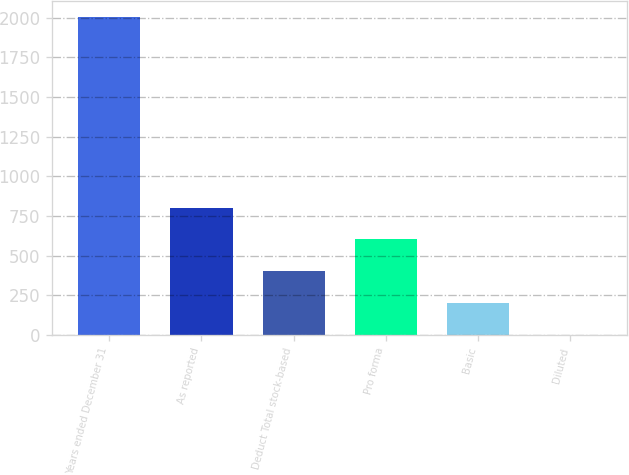Convert chart. <chart><loc_0><loc_0><loc_500><loc_500><bar_chart><fcel>Years ended December 31<fcel>As reported<fcel>Deduct Total stock-based<fcel>Pro forma<fcel>Basic<fcel>Diluted<nl><fcel>2004<fcel>802.3<fcel>401.74<fcel>602.02<fcel>201.46<fcel>1.18<nl></chart> 